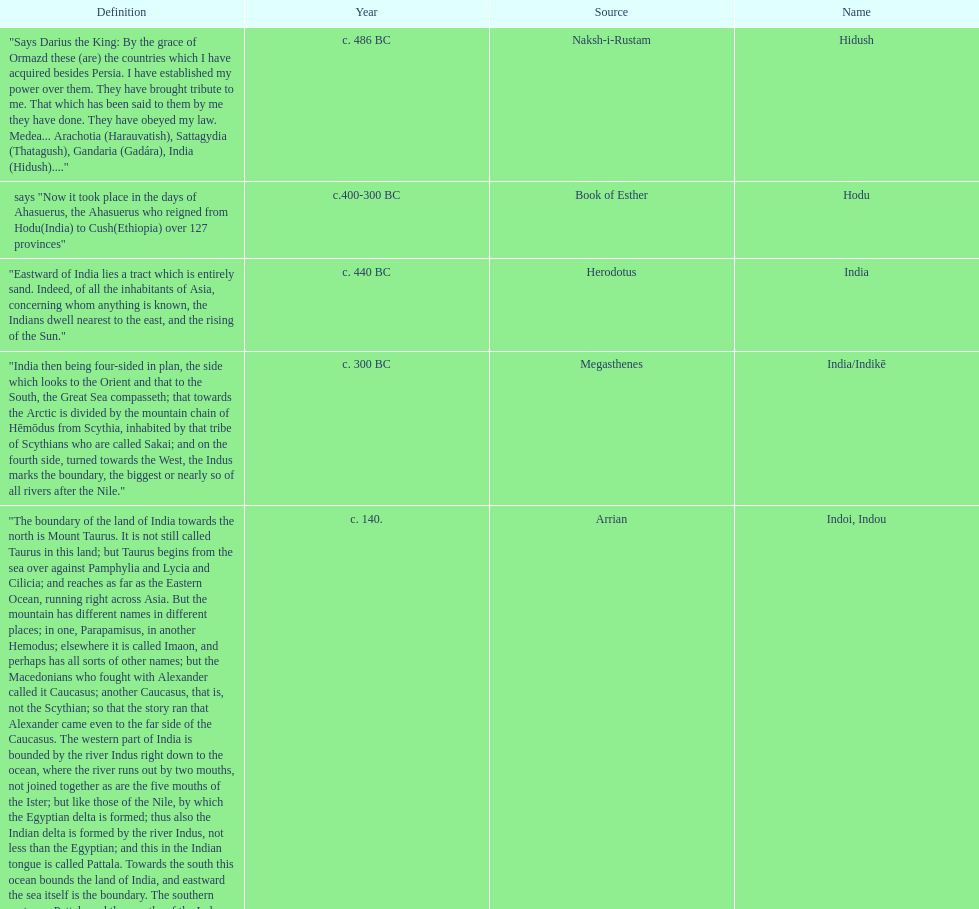Which is the most recent source for the name? Clavijo. 